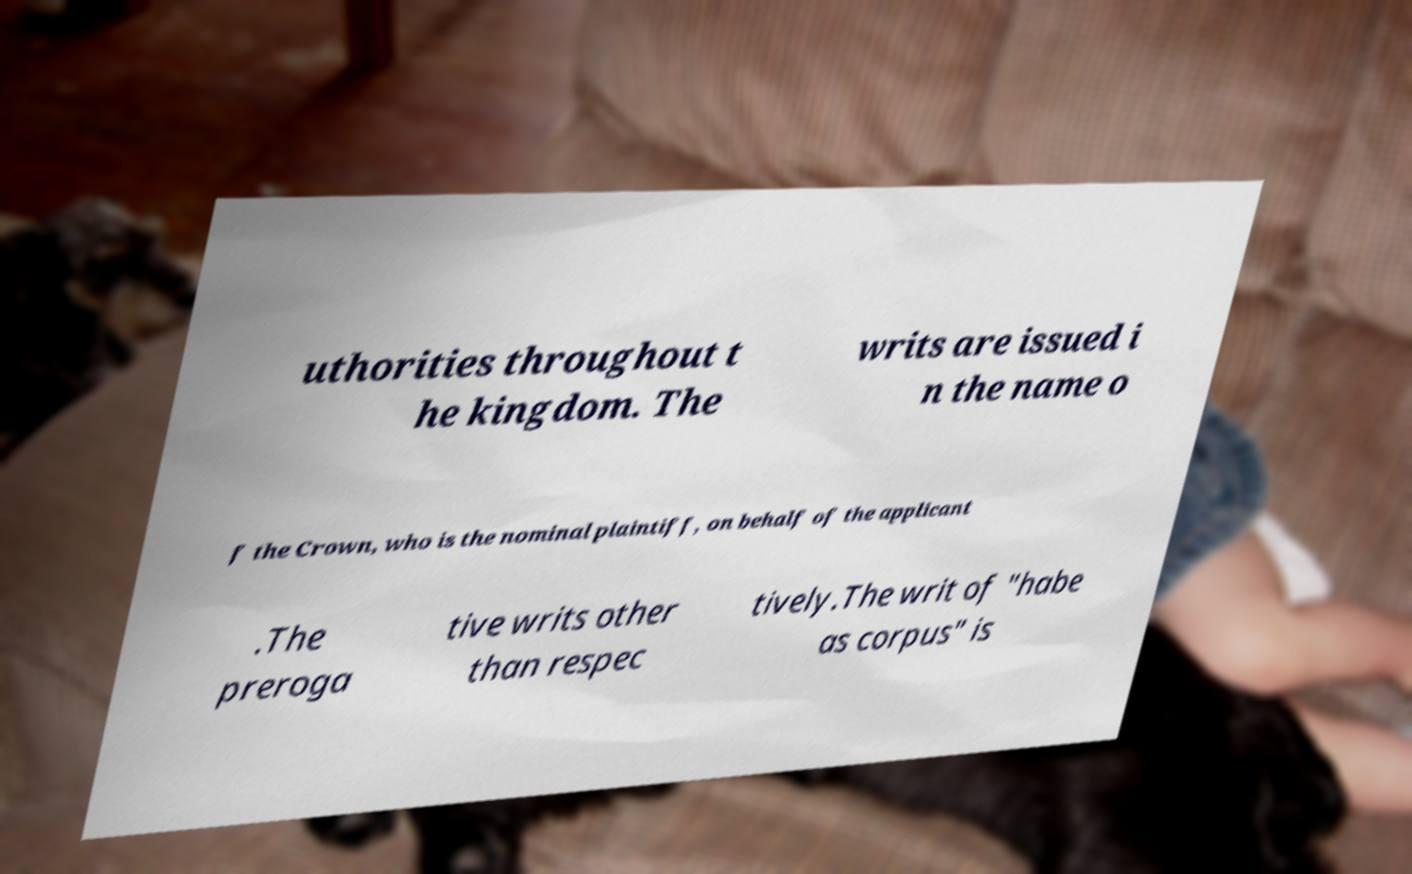Please identify and transcribe the text found in this image. uthorities throughout t he kingdom. The writs are issued i n the name o f the Crown, who is the nominal plaintiff, on behalf of the applicant .The preroga tive writs other than respec tively.The writ of "habe as corpus" is 